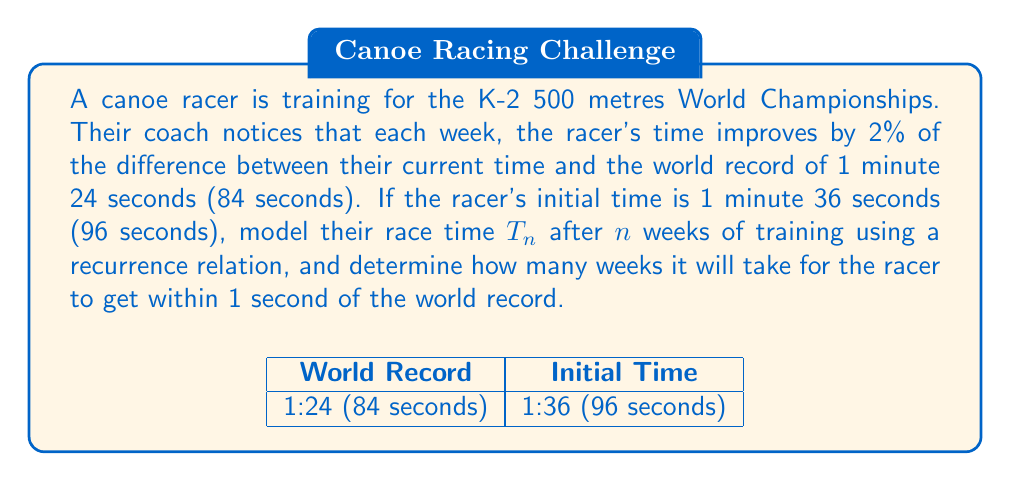Solve this math problem. Step 1: Set up the recurrence relation
Let $T_n$ be the race time in seconds after $n$ weeks of training.
Initial time: $T_0 = 96$ seconds
World record: $W = 84$ seconds

The recurrence relation can be written as:
$$T_{n+1} = T_n - 0.02(T_n - W)$$
$$T_{n+1} = T_n - 0.02(T_n - 84)$$
$$T_{n+1} = 0.98T_n + 1.68$$

Step 2: Solve the recurrence relation
The general solution for this linear recurrence relation is:
$$T_n = 84 + 12(0.98)^n$$

Step 3: Determine when the time is within 1 second of the world record
We need to find $n$ such that $T_n - 84 < 1$

$$84 + 12(0.98)^n - 84 < 1$$
$$12(0.98)^n < 1$$
$$(0.98)^n < \frac{1}{12}$$

Step 4: Solve for $n$ using logarithms
$$n \log(0.98) < \log(\frac{1}{12})$$
$$n > \frac{\log(\frac{1}{12})}{\log(0.98)} \approx 124.7$$

Therefore, it will take 125 weeks (rounding up to the nearest whole week) for the racer to get within 1 second of the world record.
Answer: 125 weeks 